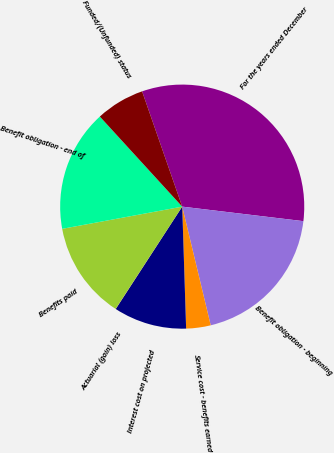Convert chart to OTSL. <chart><loc_0><loc_0><loc_500><loc_500><pie_chart><fcel>For the years ended December<fcel>Benefit obligation - beginning<fcel>Service cost - benefits earned<fcel>Interest cost on projected<fcel>Actuarial (gain) loss<fcel>Benefits paid<fcel>Benefit obligation - end of<fcel>Funded/(Unfunded) status<nl><fcel>32.23%<fcel>19.35%<fcel>3.24%<fcel>9.68%<fcel>0.02%<fcel>12.9%<fcel>16.12%<fcel>6.46%<nl></chart> 